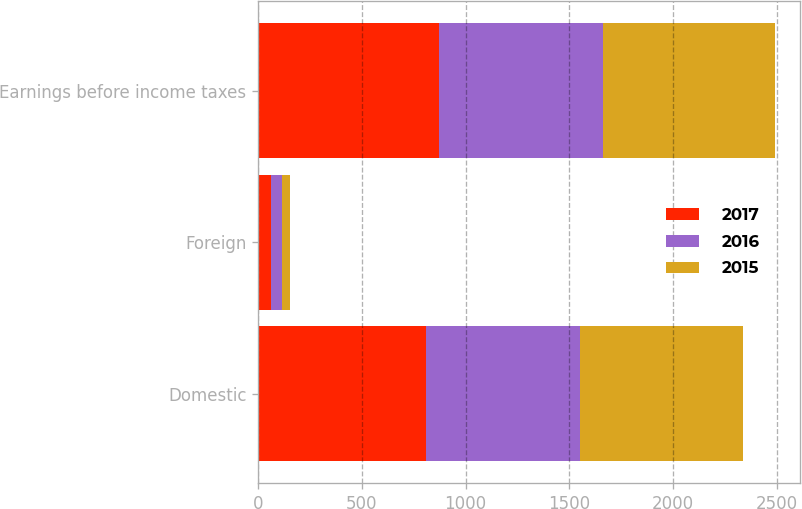Convert chart. <chart><loc_0><loc_0><loc_500><loc_500><stacked_bar_chart><ecel><fcel>Domestic<fcel>Foreign<fcel>Earnings before income taxes<nl><fcel>2017<fcel>809.4<fcel>63.7<fcel>873.1<nl><fcel>2016<fcel>739.4<fcel>50.3<fcel>789.7<nl><fcel>2015<fcel>786<fcel>40.1<fcel>826.1<nl></chart> 